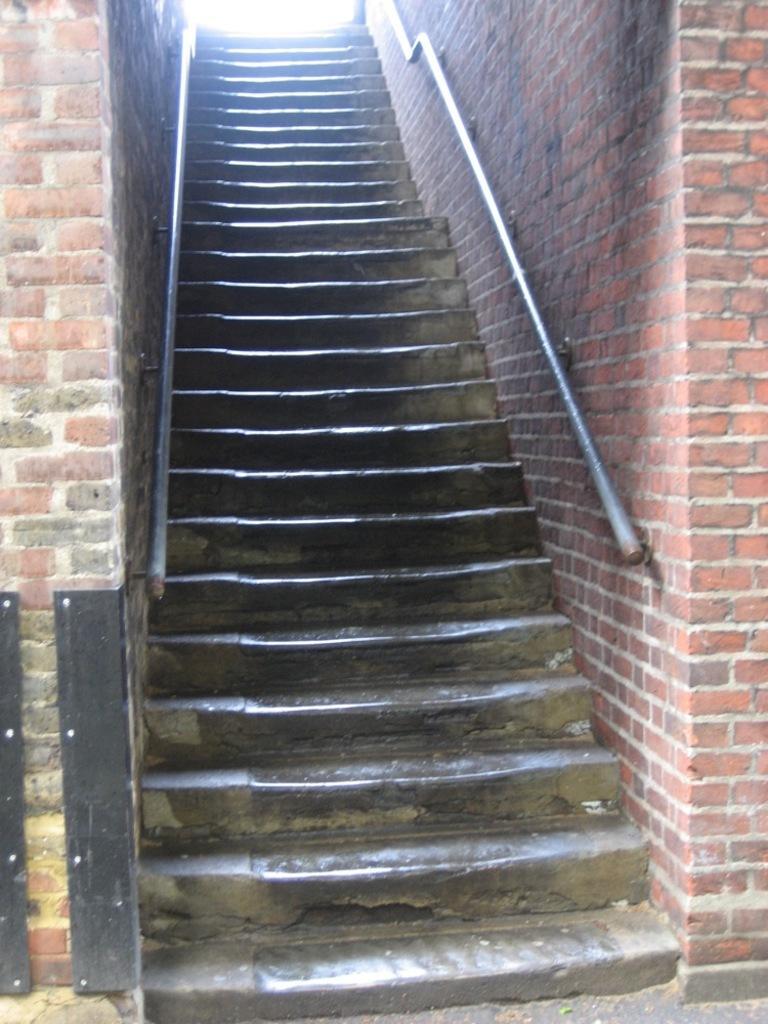Can you describe this image briefly? In this picture we can see stairs. There are railing rods. On the right and left side of the picture we can see the walls with bricks. In the bottom the left corner we can see metal stands in black color. 